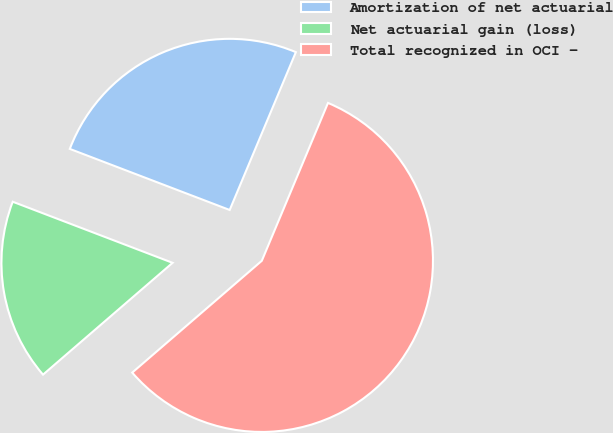Convert chart. <chart><loc_0><loc_0><loc_500><loc_500><pie_chart><fcel>Amortization of net actuarial<fcel>Net actuarial gain (loss)<fcel>Total recognized in OCI -<nl><fcel>25.51%<fcel>17.14%<fcel>57.35%<nl></chart> 